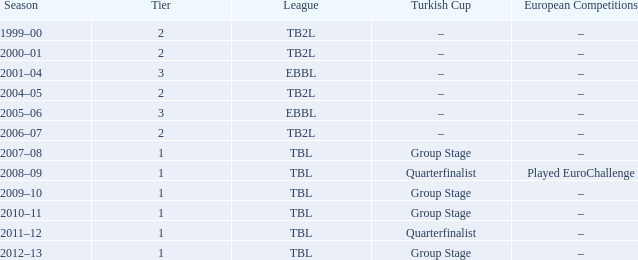Tier of 2, and a Season of 2000–01 is what European competitions? –. 